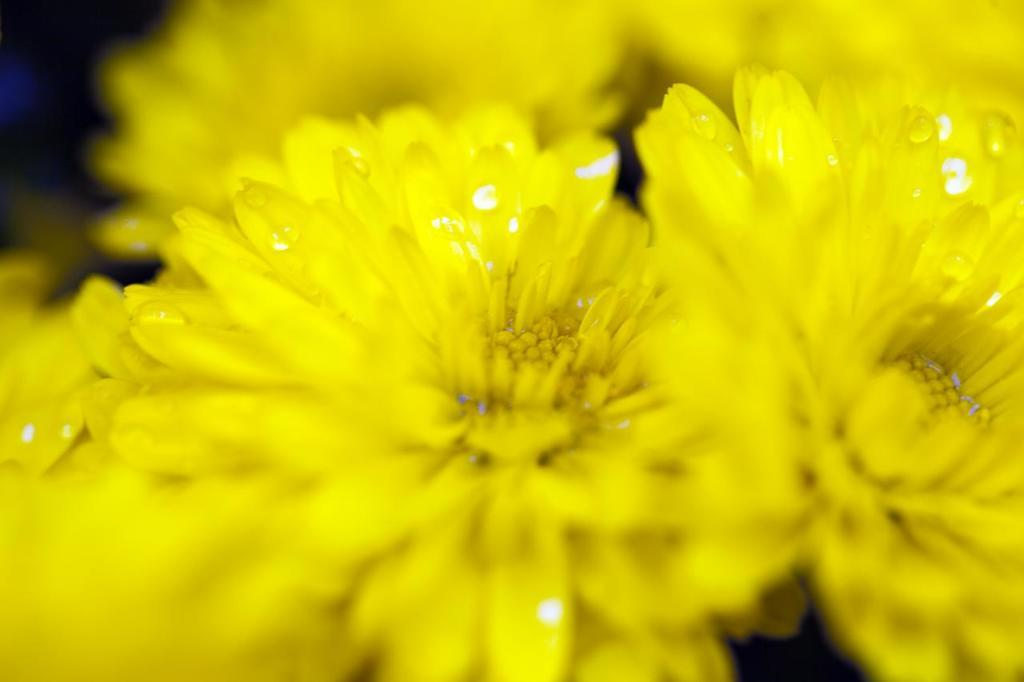What type of flowers can be seen in the image? There are yellow flowers in the image. What is the color of the background in the image? The background of the image is dark. Are there any buns visible in the image? There are no buns present in the image. Can you see any parents interacting with the flowers in the image? There is no indication of any parents or interactions with the flowers in the image. 